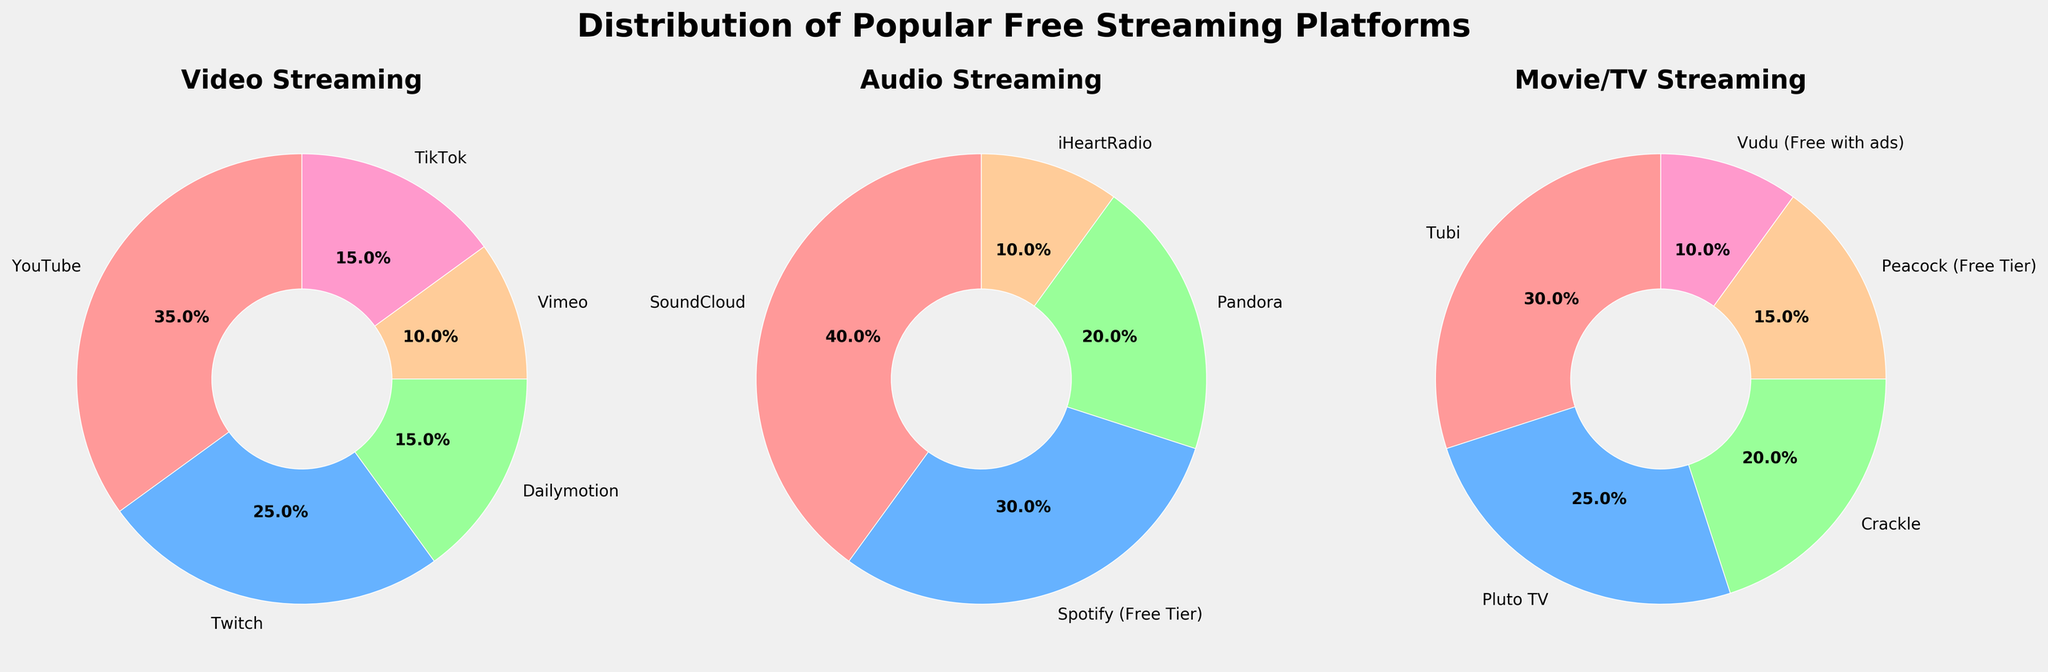What is the most popular video streaming platform among tech-savvy individuals? By looking at the pie chart for Video Streaming, we see that YouTube has the largest slice, indicating it is the most popular platform.
Answer: YouTube Which streaming platform has the highest percentage within the Audio category? In the Audio Streaming pie chart, SoundCloud has the largest slice, representing the highest percentage.
Answer: SoundCloud How do the market shares of Tubi and Pluto TV compare in the Movie/TV streaming category? In the Movie/TV Streaming pie chart, Tubi has a larger slice at 30%, while Pluto TV has 25%, so Tubi has a higher market share.
Answer: Tubi What's the combined percentage of Dailymotion and Vimeo for video streaming? In the Video Streaming pie chart, Dailymotion is 15% and Vimeo is 10%. Combining them gives 15% + 10% = 25%.
Answer: 25% Which Movie/TV streaming platform has the lowest percentage of users, and what is that percentage? The pie chart for Movie/TV Streaming shows that Vudu (Free with ads) has the smallest slice, representing the lowest percentage of 10%.
Answer: Vudu (Free with ads), 10% Compare the market share of Spotify (Free Tier) to iHeartRadio in the Audio category. In the Audio Streaming pie chart, Spotify (Free Tier) has a 30% share, while iHeartRadio has 10%, so Spotify (Free Tier) has a higher market share.
Answer: Spotify (Free Tier) Which category has the largest number of platforms listed? Each pie chart shows the number of platforms: Video has 5, Audio has 4, and Movie/TV also has 5. Thus, the Video and Movie/TV categories both tie for the largest number of platforms listed.
Answer: Video and Movie/TV What is the total market share percentage of all Movie/TV streaming platforms combined? Adding up the percentages for Movie/TV Streaming, we get Tubi (30%) + Pluto TV (25%) + Crackle (20%) + Peacock (Free Tier) (15%) + Vudu (Free with ads) (10%) = 100%.
Answer: 100% What percentage of the tech-savvy individuals use Twitch and TikTok for video streaming? The pie chart for Video Streaming shows Twitch at 25% and TikTok at 15%. So, combined, it is 25% + 15% = 40%.
Answer: 40% 